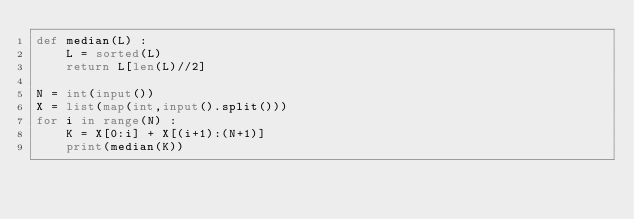Convert code to text. <code><loc_0><loc_0><loc_500><loc_500><_Python_>def median(L) :
    L = sorted(L)
    return L[len(L)//2]

N = int(input())
X = list(map(int,input().split()))
for i in range(N) :
    K = X[0:i] + X[(i+1):(N+1)]
    print(median(K))
</code> 